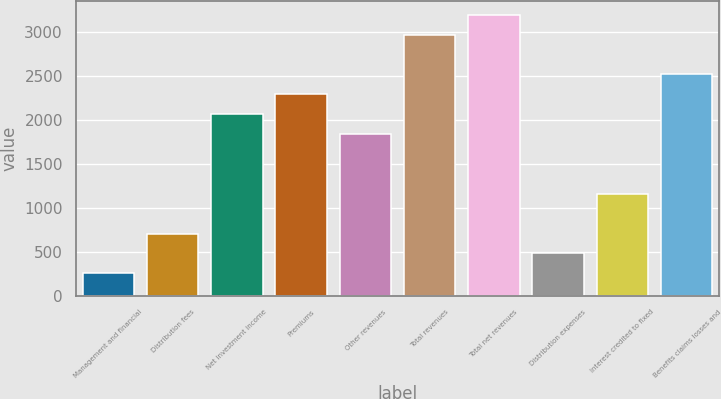Convert chart to OTSL. <chart><loc_0><loc_0><loc_500><loc_500><bar_chart><fcel>Management and financial<fcel>Distribution fees<fcel>Net investment income<fcel>Premiums<fcel>Other revenues<fcel>Total revenues<fcel>Total net revenues<fcel>Distribution expenses<fcel>Interest credited to fixed<fcel>Benefits claims losses and<nl><fcel>253.9<fcel>705.7<fcel>2061.1<fcel>2287<fcel>1835.2<fcel>2964.7<fcel>3190.6<fcel>479.8<fcel>1157.5<fcel>2512.9<nl></chart> 